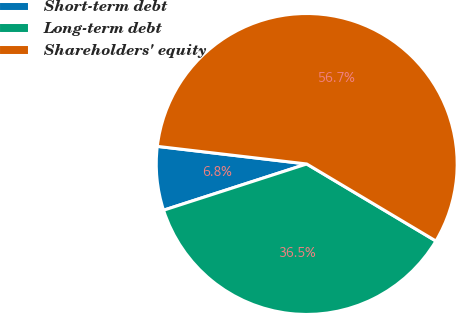<chart> <loc_0><loc_0><loc_500><loc_500><pie_chart><fcel>Short-term debt<fcel>Long-term debt<fcel>Shareholders' equity<nl><fcel>6.84%<fcel>36.47%<fcel>56.69%<nl></chart> 